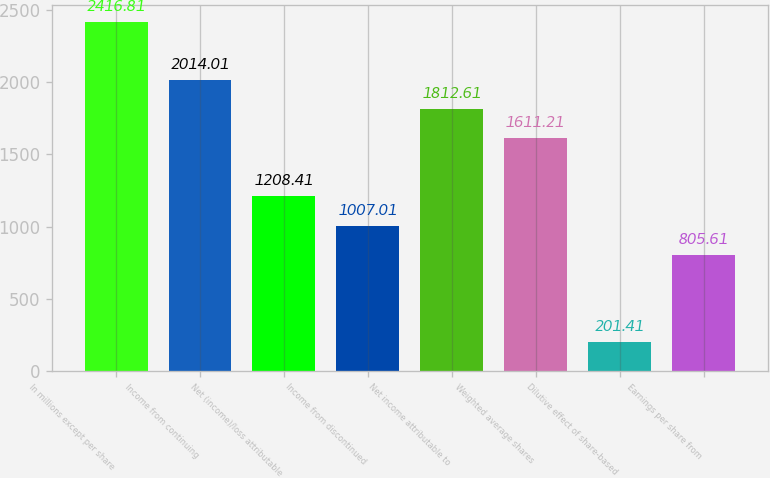<chart> <loc_0><loc_0><loc_500><loc_500><bar_chart><fcel>In millions except per share<fcel>Income from continuing<fcel>Net (income)/loss attributable<fcel>Income from discontinued<fcel>Net income attributable to<fcel>Weighted average shares<fcel>Dilutive effect of share-based<fcel>Earnings per share from<nl><fcel>2416.81<fcel>2014.01<fcel>1208.41<fcel>1007.01<fcel>1812.61<fcel>1611.21<fcel>201.41<fcel>805.61<nl></chart> 